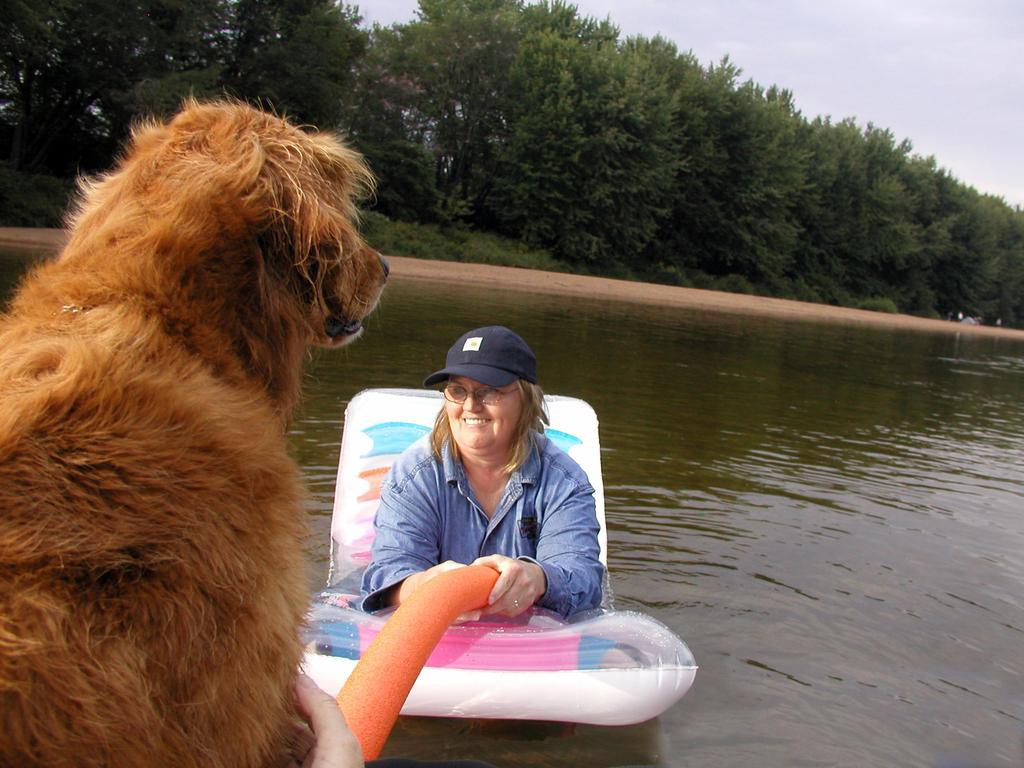In one or two sentences, can you explain what this image depicts? In the picture I can see a woman sitting on an object which is on the water and holding an object in her hands and there is a dog in front of her in the left corner and there are trees in the background. 